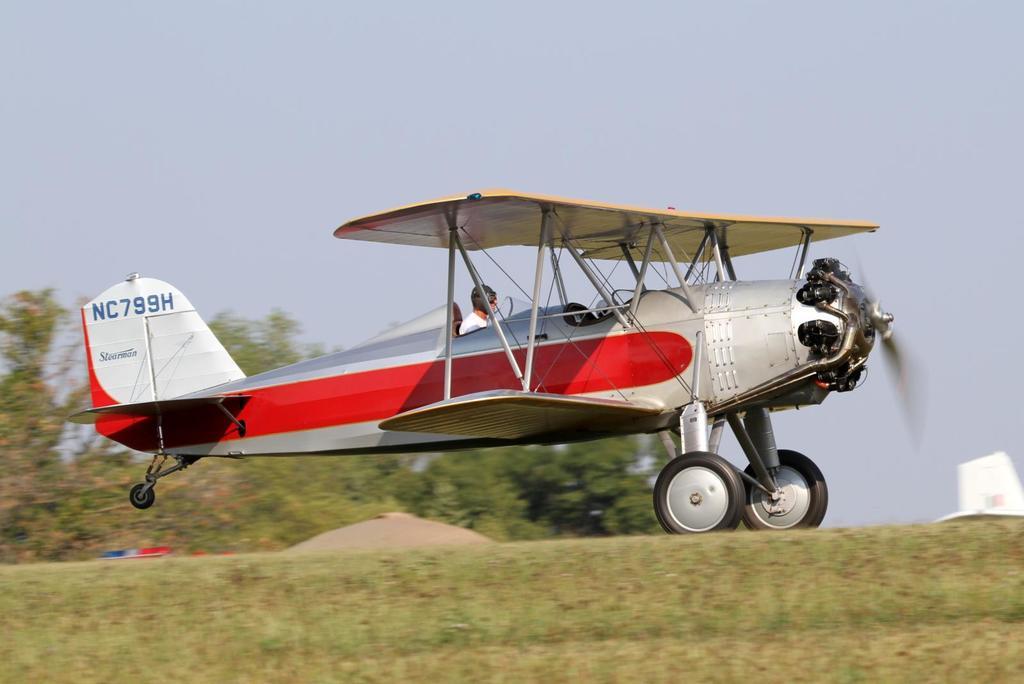What is the plane's serial number?
Give a very brief answer. Nc799h. Who many people here?
Your answer should be compact. 1. 